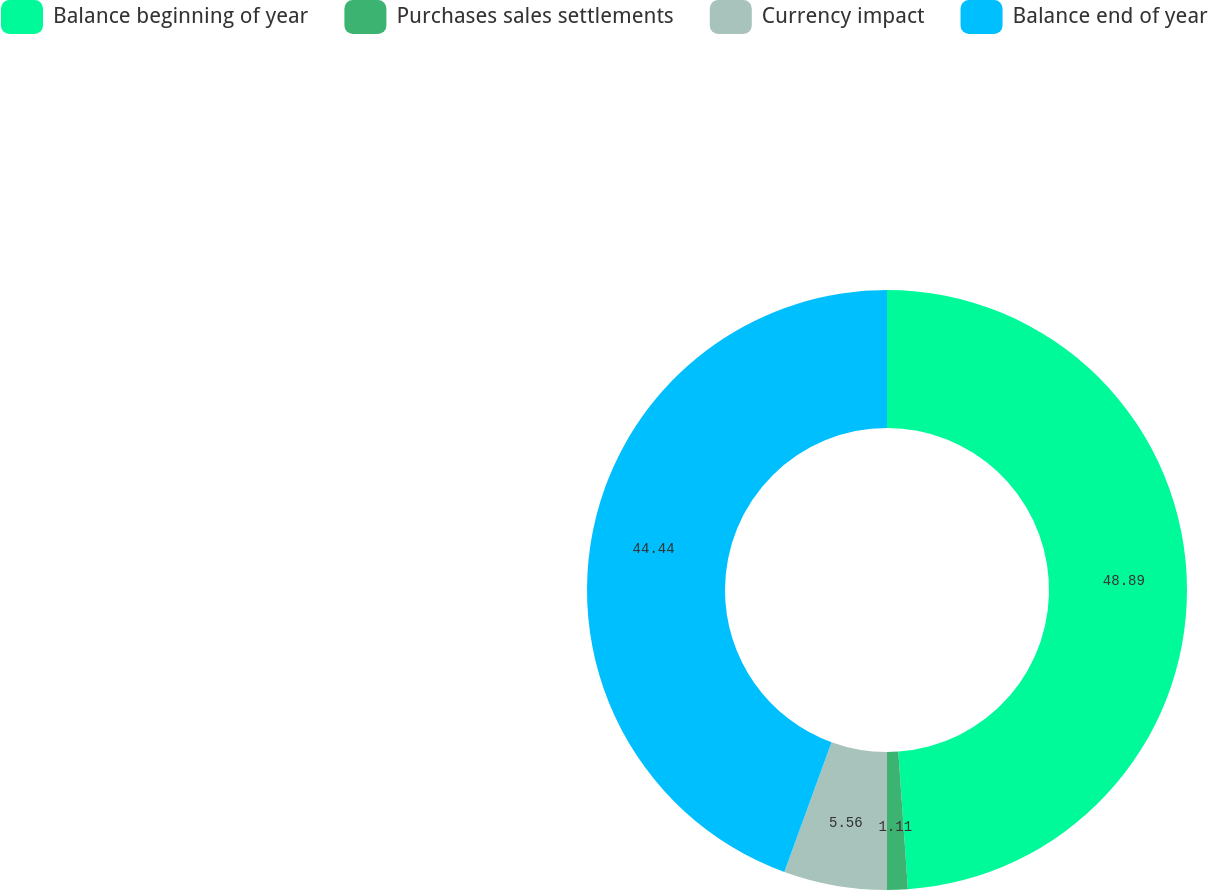Convert chart to OTSL. <chart><loc_0><loc_0><loc_500><loc_500><pie_chart><fcel>Balance beginning of year<fcel>Purchases sales settlements<fcel>Currency impact<fcel>Balance end of year<nl><fcel>48.89%<fcel>1.11%<fcel>5.56%<fcel>44.44%<nl></chart> 